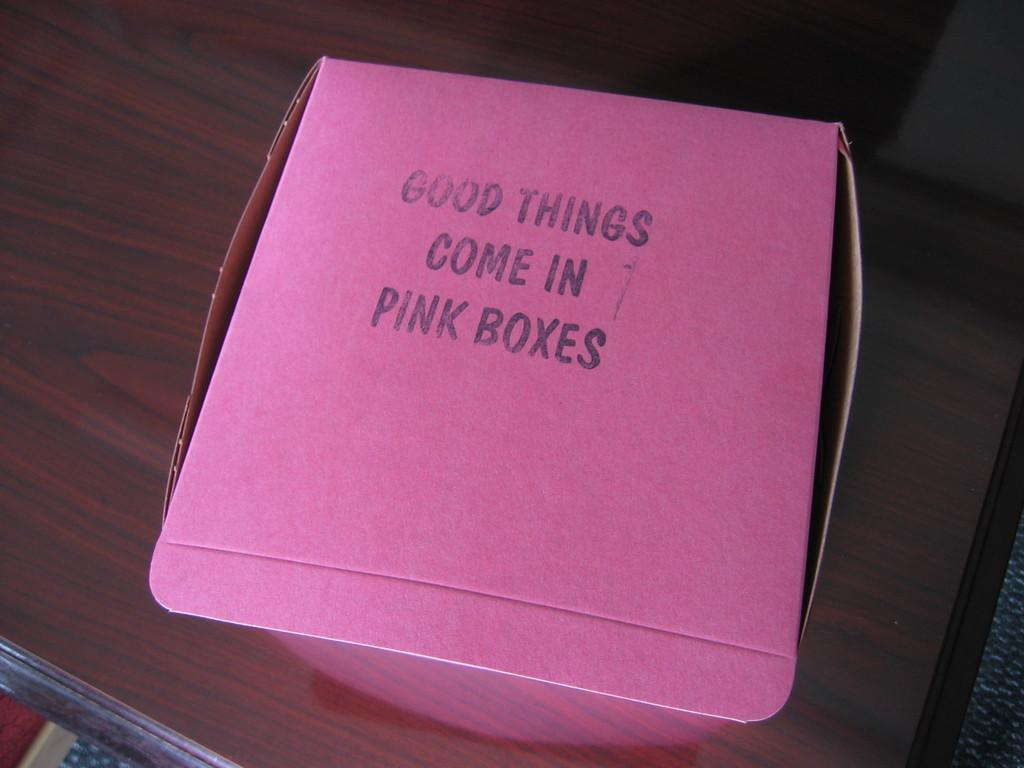<image>
Offer a succinct explanation of the picture presented. Well this claims that good things come in pink boxes. 